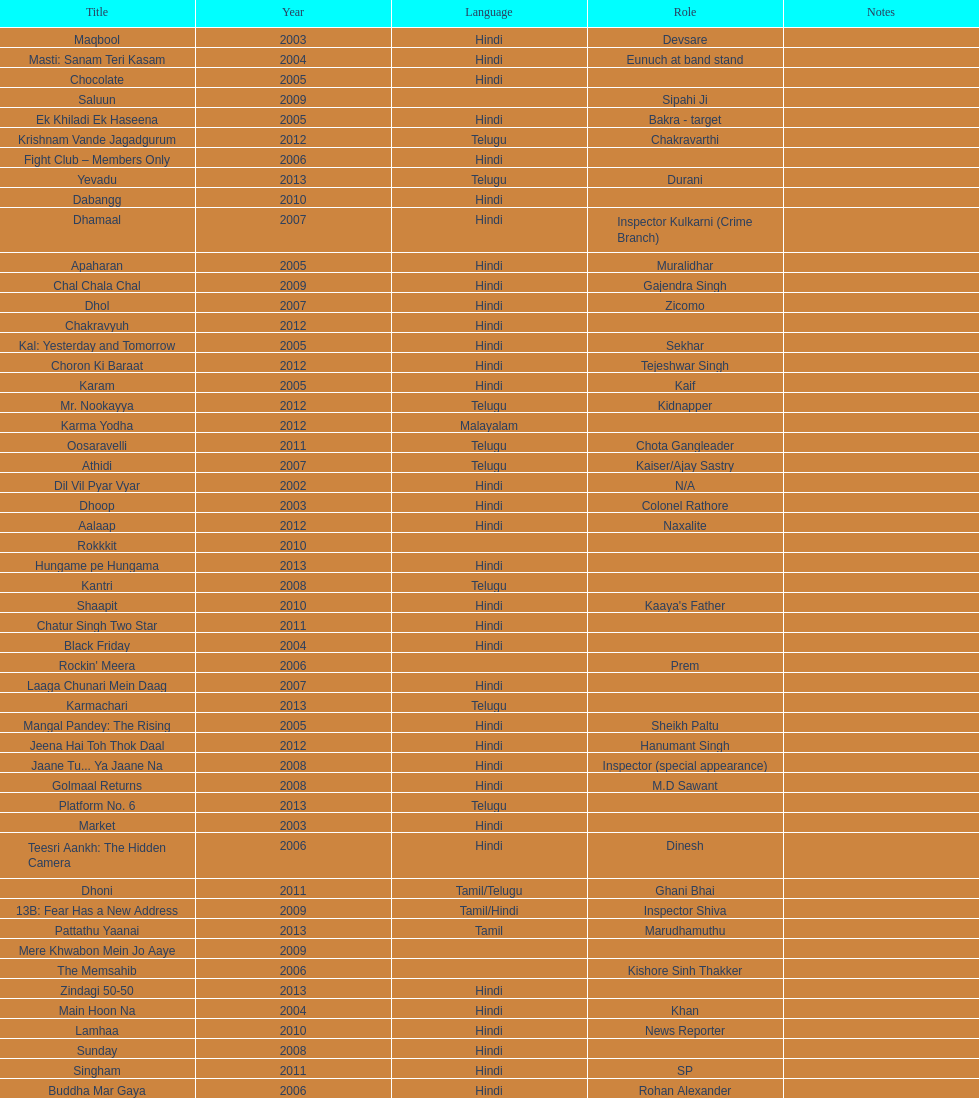What title is before dhol in 2007? Dhamaal. 